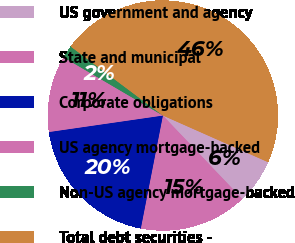<chart> <loc_0><loc_0><loc_500><loc_500><pie_chart><fcel>US government and agency<fcel>State and municipal<fcel>Corporate obligations<fcel>US agency mortgage-backed<fcel>Non-US agency mortgage-backed<fcel>Total debt securities -<nl><fcel>6.25%<fcel>15.18%<fcel>19.64%<fcel>10.72%<fcel>1.79%<fcel>46.42%<nl></chart> 